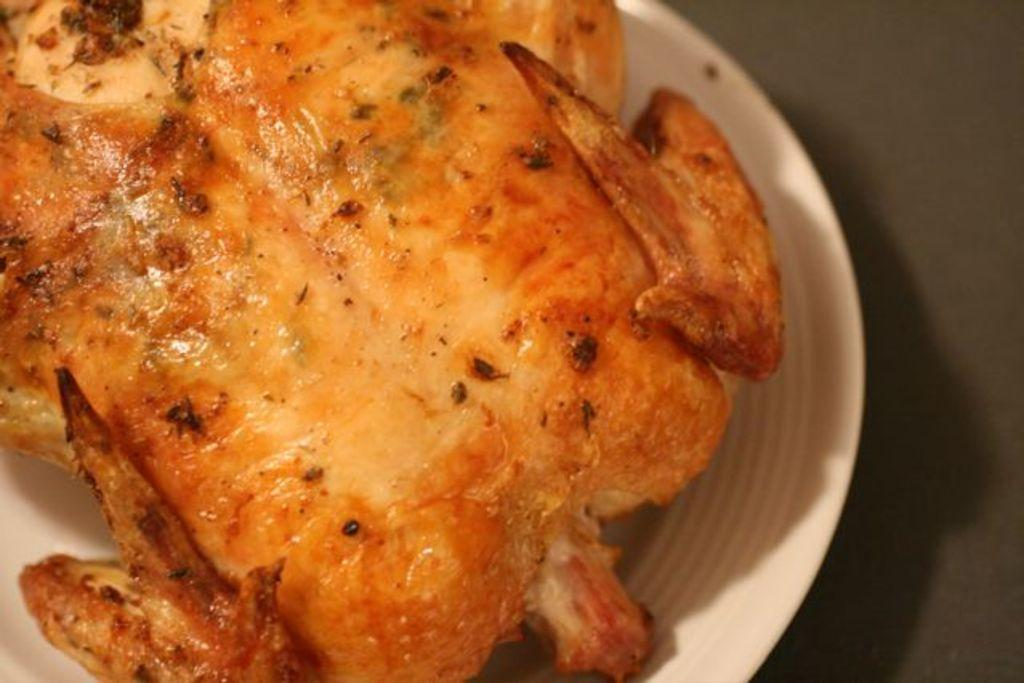What type of food is visible in the image? There is a roasted chicken piece in the image. What is the color of the plate on which the chicken piece is placed? The chicken piece is on a white color plate. What type of territory is being claimed by the chicken piece in the image? There is no indication of territory being claimed in the image; it simply shows a roasted chicken piece on a white plate. 